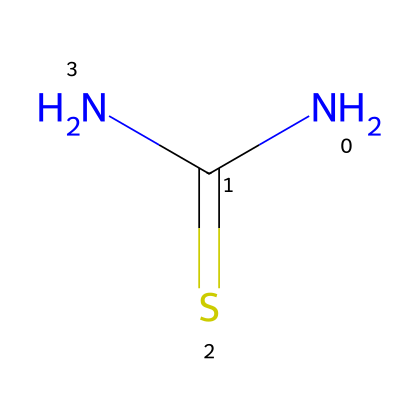what is the name of this chemical? The SMILES representation NC(=S)N corresponds to thiourea, which is a well-known sulfur compound used in various applications, including photography.
Answer: thiourea how many nitrogen atoms are present in this structure? Analyzing the SMILES representation, we see two nitrogen atoms (N) in the formula. Each 'N' in the structure indicates one nitrogen atom.
Answer: 2 how many total atoms are in this thiourea molecule? The SMILES indicates two nitrogen (N) atoms, one carbon (C) atom, and one sulfur (S) atom, totaling four atoms. Therefore, 2 + 1 + 1 = 4.
Answer: 4 which group in thiourea makes it a sulfur compound? The presence of the sulfur atom (S) in the chemical structure is what categorizes thiourea as a sulfur compound. The carbon is double bonded to sulfur in the structure.
Answer: sulfur what type of bonding is present between the carbon and sulfur in thiourea? In the structure NC(=S)N, the carbon is double bonded to sulfur, which is indicated by the '=' sign in the SMILES representation. This shows a double bond between C and S.
Answer: double bond what characteristic feature of thiourea allows it to act as a reducing agent in photography? The functional groups, particularly the presence of nitrogen atoms attached to the carbon and sulfur, contribute to thiourea's ability to donate electrons, acting as a reducing agent.
Answer: reducing agent what could be a potential waste material when using thiourea in photographic processes? During the development process, residual thiourea can remain after the photographic reaction, potentially leading to waste that could be repurposed if properly managed.
Answer: residual thiourea 